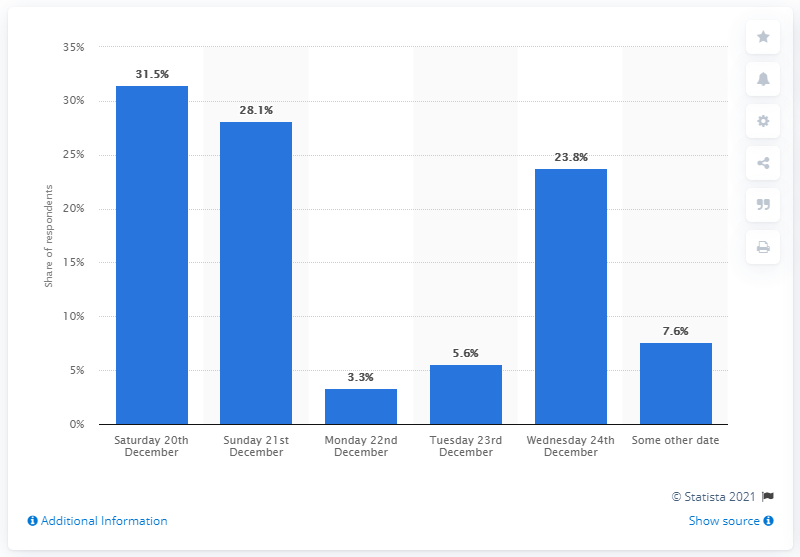Outline some significant characteristics in this image. It is expected that Monday, December 22nd will be the least busy day for Christmas shoppers. According to 